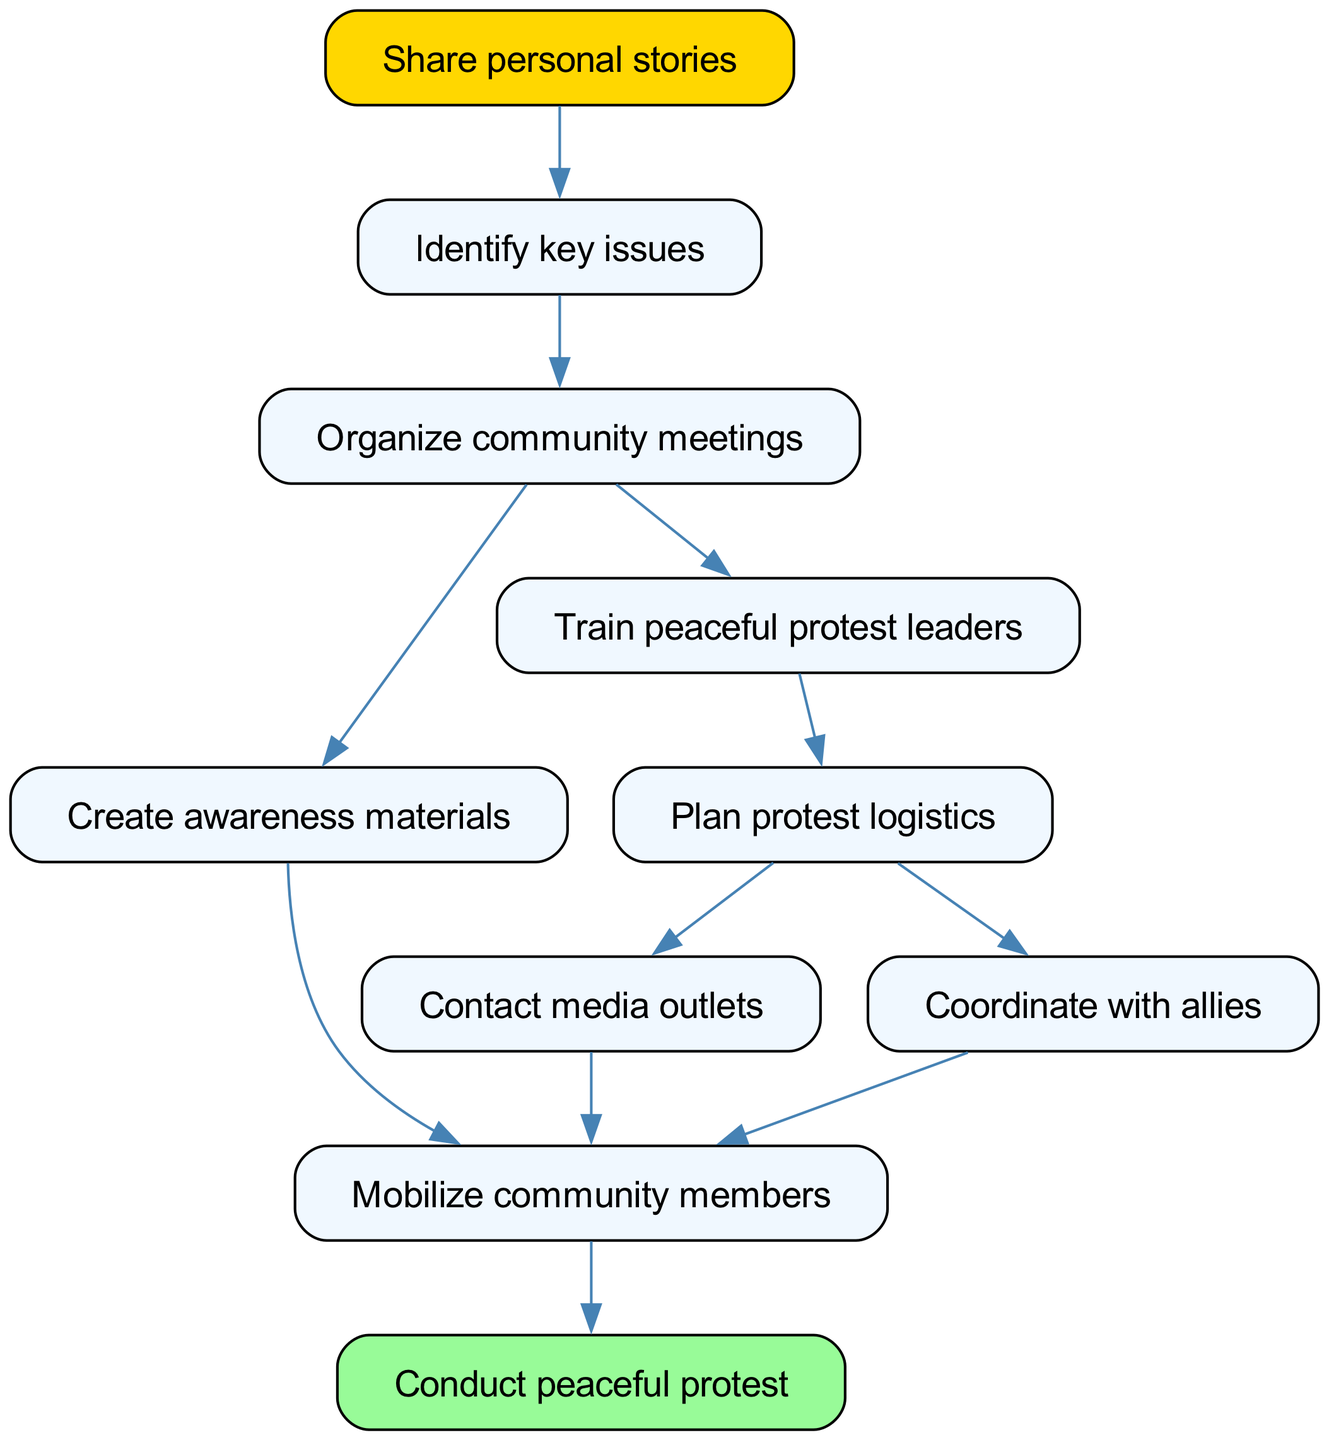What is the first step in the mobilization process? The first step is "Share personal stories," as it is the starting point in the directed graph indicated by its position at the top and no incoming edges.
Answer: Share personal stories How many nodes are in the diagram? By counting the unique points in the diagram, we find there are 10 distinct nodes representing the various stages of mobilization.
Answer: 10 What follows after "Organize community meetings"? The two subsequent steps after "Organize community meetings" are "Create awareness materials" and "Train peaceful protest leaders," as these are directly linked by outgoing edges from that node.
Answer: Create awareness materials, Train peaceful protest leaders What is the final action in the mobilization process? The final action is "Conduct peaceful protest," which is found at the bottom of the flowchart and has only incoming edges from "Mobilize community members."
Answer: Conduct peaceful protest How many edges connect to "Mobilize community members"? "Mobilize community members" has three incoming edges from "Create awareness materials," "Contact media outlets," and "Coordinate with allies," indicating that it receives information or action from multiple previous steps.
Answer: 3 Which nodes directly lead to "Plan protest logistics"? The only direct predecessor leading to "Plan protest logistics" is "Train peaceful protest leaders," indicated by a single edge coming into this node.
Answer: Train peaceful protest leaders What is the relationship between "Contact media outlets" and "Mobilize community members"? There is a direct edge from "Contact media outlets" to "Mobilize community members," indicating that once media outlets are contacted, it helps in mobilizing community members for the protest.
Answer: Direct relationship What step involves the creation of materials to raise awareness? The step involved in creating materials to raise awareness is "Create awareness materials," which follows directly after organizing community meetings.
Answer: Create awareness materials Which process contributes to training leaders for protests? The process contributing to training leaders for protests is "Train peaceful protest leaders," which is linked from "Organize community meetings."
Answer: Train peaceful protest leaders 